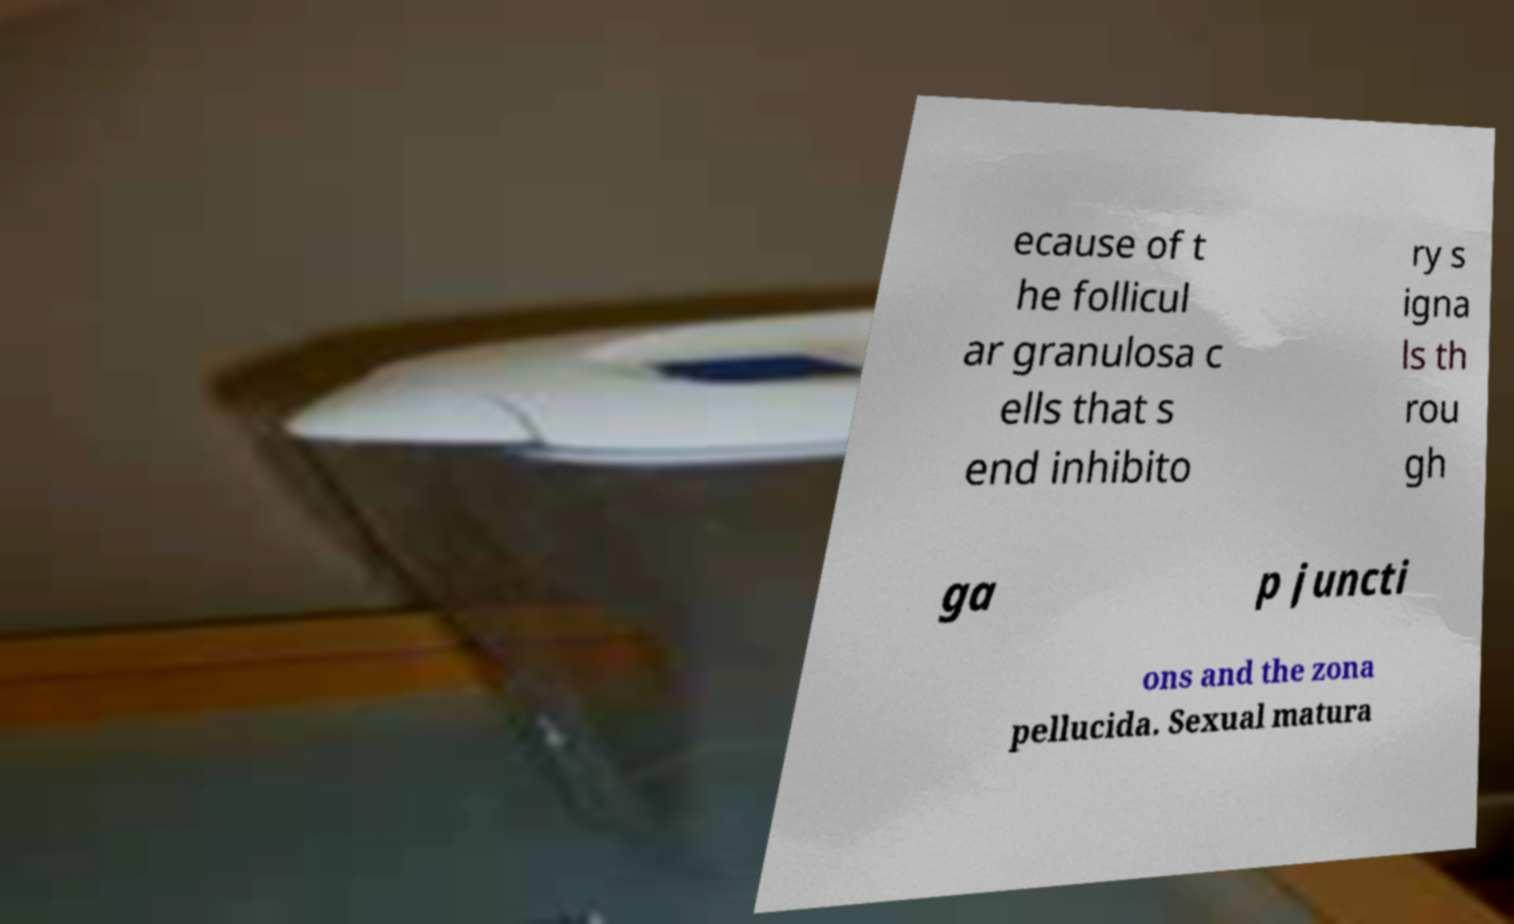There's text embedded in this image that I need extracted. Can you transcribe it verbatim? ecause of t he follicul ar granulosa c ells that s end inhibito ry s igna ls th rou gh ga p juncti ons and the zona pellucida. Sexual matura 